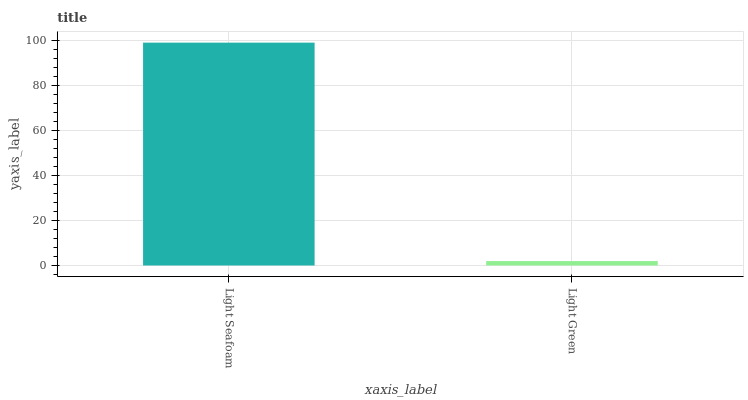Is Light Green the minimum?
Answer yes or no. Yes. Is Light Seafoam the maximum?
Answer yes or no. Yes. Is Light Green the maximum?
Answer yes or no. No. Is Light Seafoam greater than Light Green?
Answer yes or no. Yes. Is Light Green less than Light Seafoam?
Answer yes or no. Yes. Is Light Green greater than Light Seafoam?
Answer yes or no. No. Is Light Seafoam less than Light Green?
Answer yes or no. No. Is Light Seafoam the high median?
Answer yes or no. Yes. Is Light Green the low median?
Answer yes or no. Yes. Is Light Green the high median?
Answer yes or no. No. Is Light Seafoam the low median?
Answer yes or no. No. 